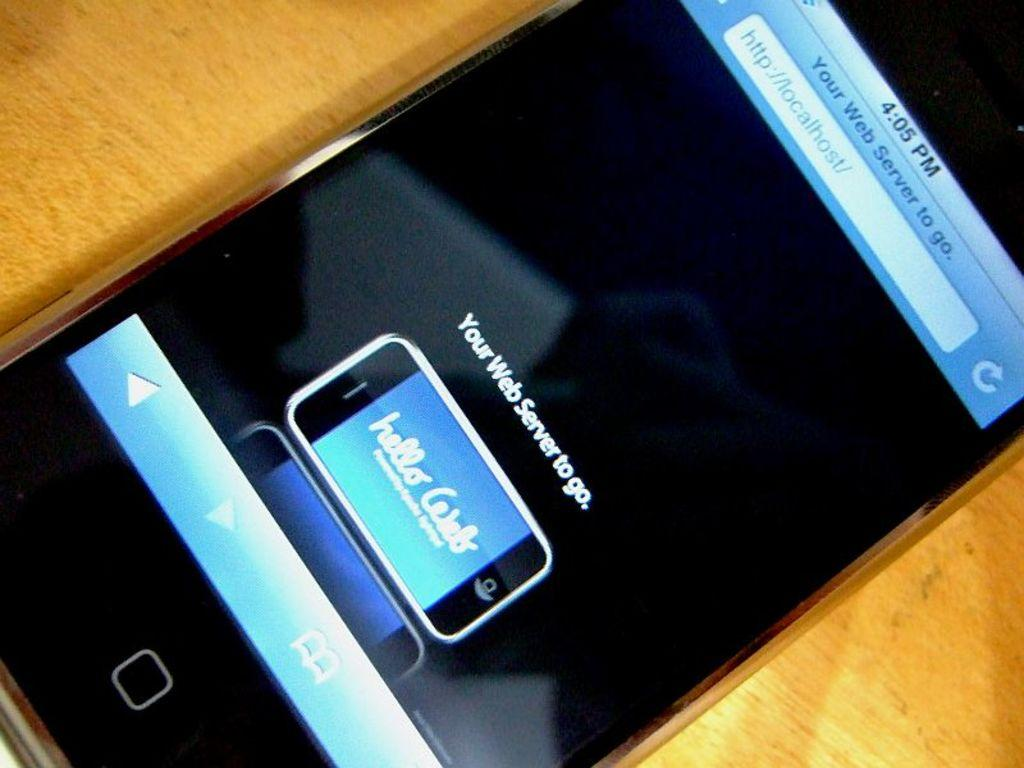Provide a one-sentence caption for the provided image. A cell phone which is on the website localhost.com. 